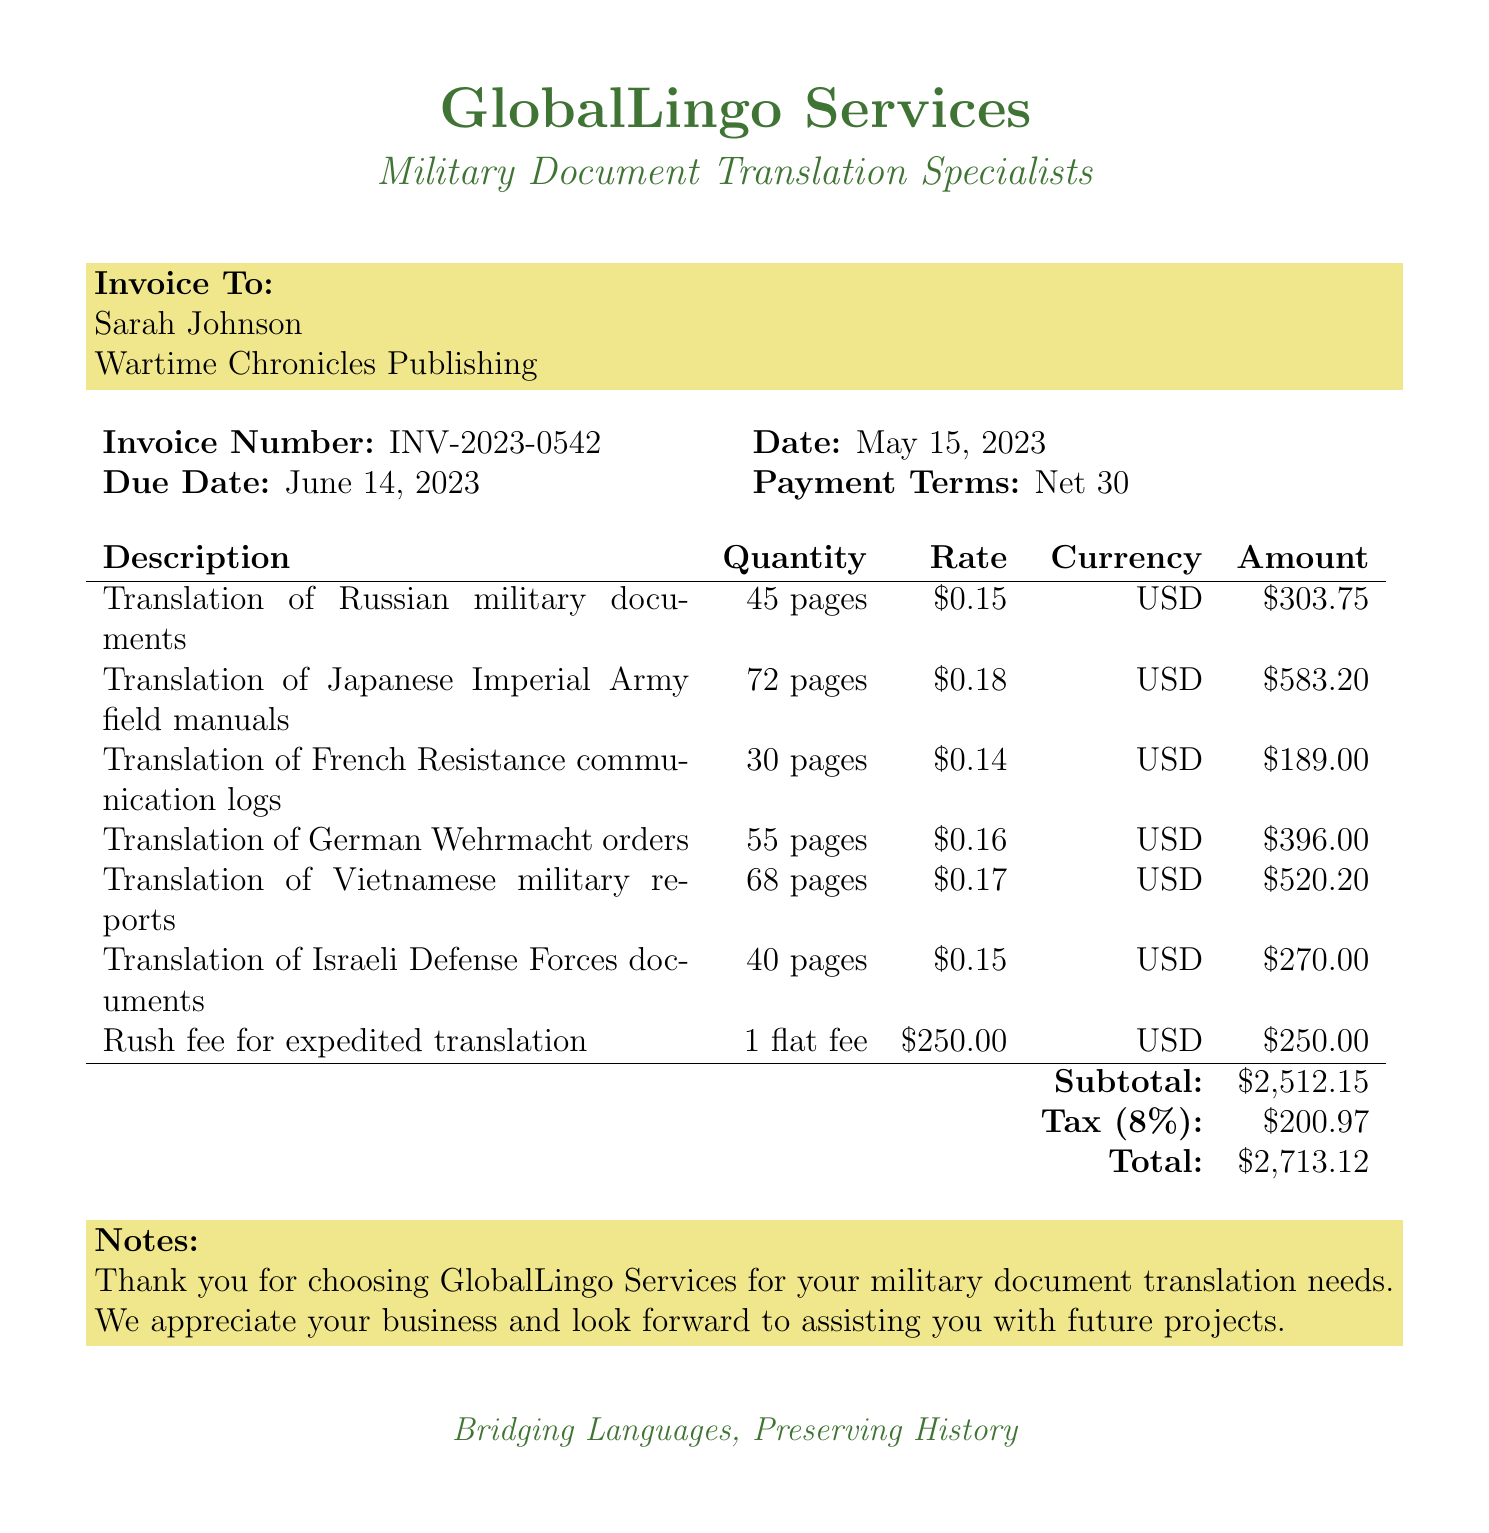What is the invoice number? The invoice number is clearly stated in the document as INV-2023-0542.
Answer: INV-2023-0542 Who is the client organization? The document specifies that the client organization is Wartime Chronicles Publishing.
Answer: Wartime Chronicles Publishing What is the total amount due? The total amount due is listed at the bottom of the invoice as $2713.12.
Answer: $2713.12 What is the quantity of pages translated for Japanese documents? The invoice indicates that 72 pages of Japanese documents were translated.
Answer: 72 pages What is the tax rate applied to the invoice? The tax rate is mentioned as 8% in the invoice.
Answer: 8% What service had a rush fee applied? The rush fee was applied for the expedited translation of classified NATO documents.
Answer: Classified NATO documents What is the due date for the invoice? The due date for payment of the invoice is specified as June 14, 2023.
Answer: June 14, 2023 How many pages were translated from the Battle of Stalingrad? The document states that 45 pages were translated from the Battle of Stalingrad.
Answer: 45 pages Who provided the translation services? The translation services were provided by GlobalLingo Services.
Answer: GlobalLingo Services 